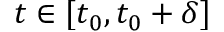Convert formula to latex. <formula><loc_0><loc_0><loc_500><loc_500>t \in [ t _ { 0 } , t _ { 0 } + \delta ]</formula> 